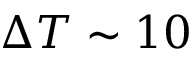Convert formula to latex. <formula><loc_0><loc_0><loc_500><loc_500>\Delta T \sim 1 0</formula> 